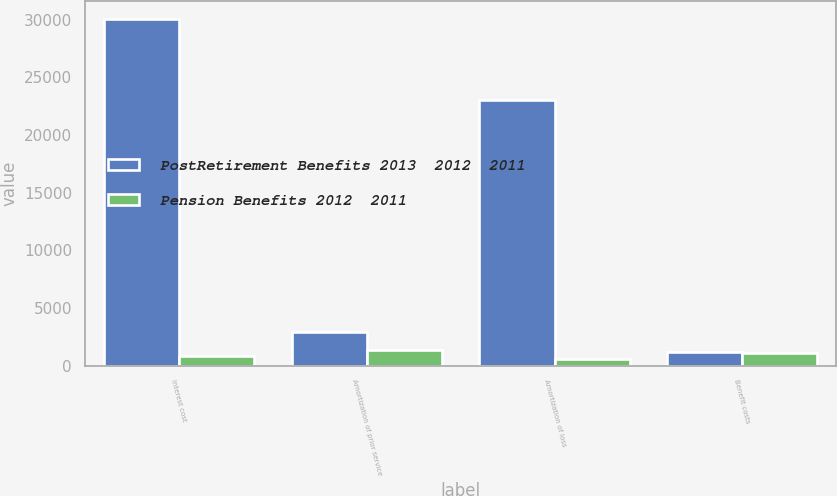Convert chart. <chart><loc_0><loc_0><loc_500><loc_500><stacked_bar_chart><ecel><fcel>Interest cost<fcel>Amortization of prior service<fcel>Amortization of loss<fcel>Benefit costs<nl><fcel>PostRetirement Benefits 2013  2012  2011<fcel>30112<fcel>2883<fcel>23044<fcel>1182<nl><fcel>Pension Benefits 2012  2011<fcel>862<fcel>1353<fcel>600<fcel>1091<nl></chart> 